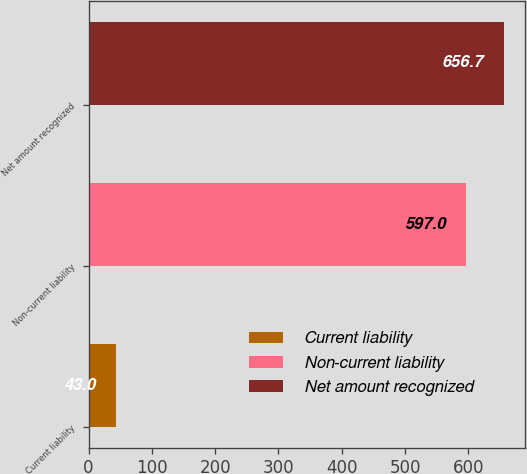Convert chart to OTSL. <chart><loc_0><loc_0><loc_500><loc_500><bar_chart><fcel>Current liability<fcel>Non-current liability<fcel>Net amount recognized<nl><fcel>43<fcel>597<fcel>656.7<nl></chart> 